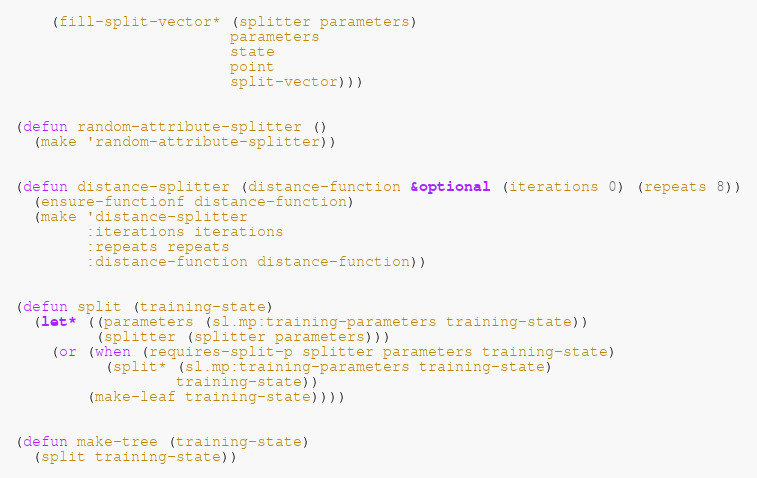Convert code to text. <code><loc_0><loc_0><loc_500><loc_500><_Lisp_>    (fill-split-vector* (splitter parameters)
                        parameters
                        state
                        point
                        split-vector)))


(defun random-attribute-splitter ()
  (make 'random-attribute-splitter))


(defun distance-splitter (distance-function &optional (iterations 0) (repeats 8))
  (ensure-functionf distance-function)
  (make 'distance-splitter
        :iterations iterations
        :repeats repeats
        :distance-function distance-function))


(defun split (training-state)
  (let* ((parameters (sl.mp:training-parameters training-state))
         (splitter (splitter parameters)))
    (or (when (requires-split-p splitter parameters training-state)
          (split* (sl.mp:training-parameters training-state)
                  training-state))
        (make-leaf training-state))))


(defun make-tree (training-state)
  (split training-state))
</code> 